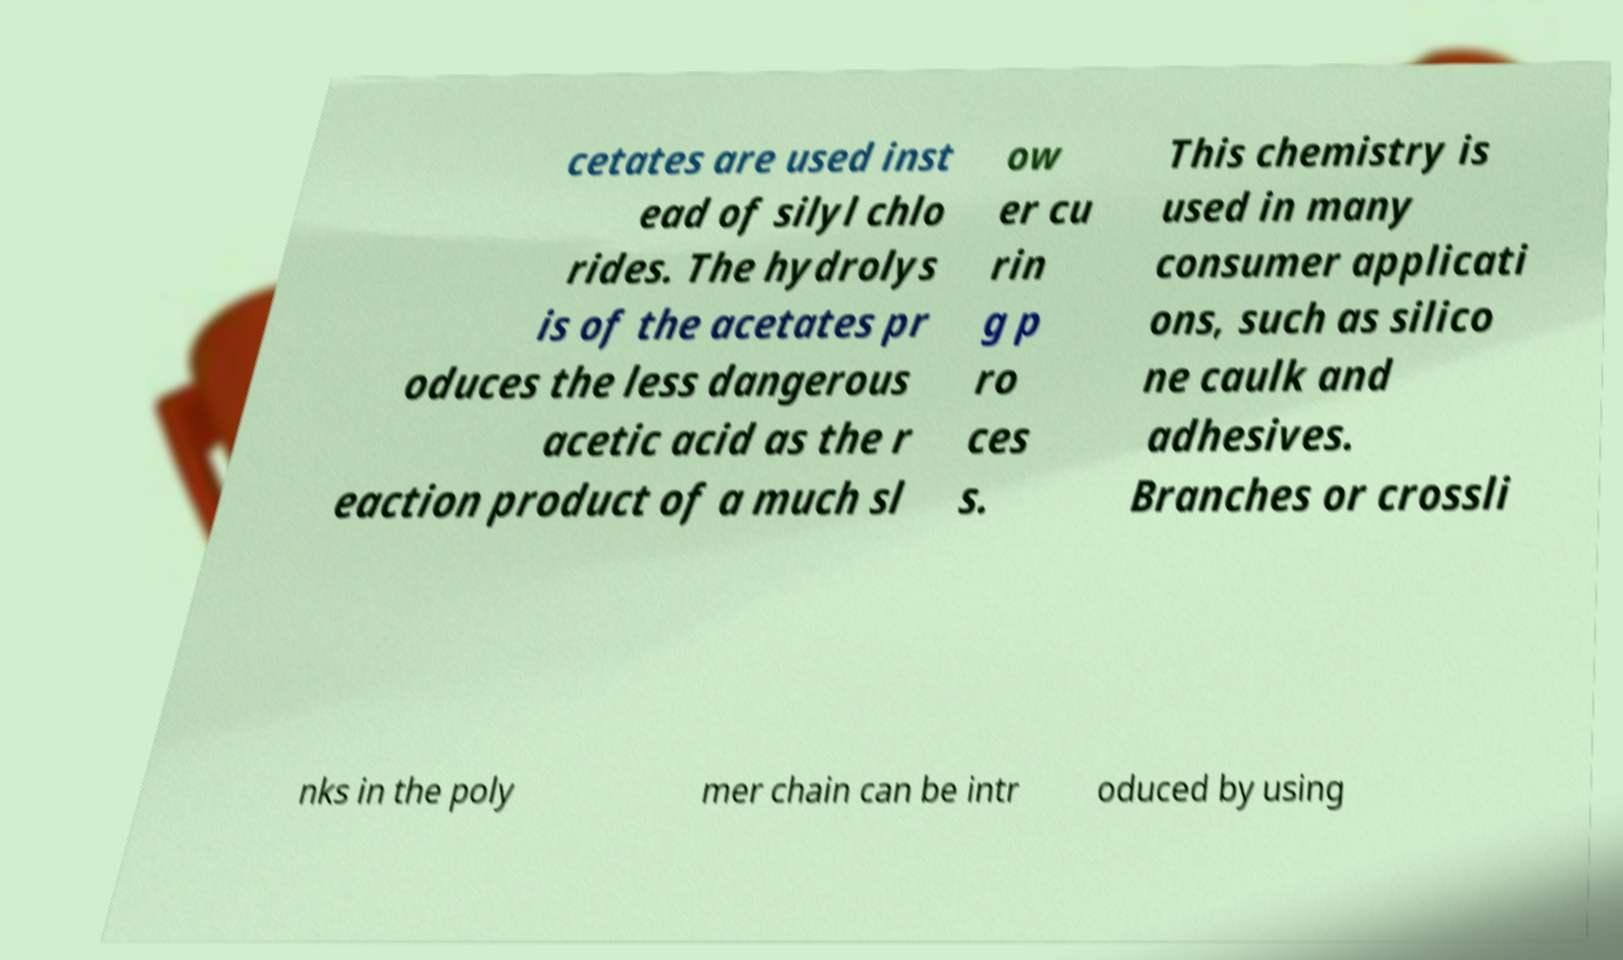For documentation purposes, I need the text within this image transcribed. Could you provide that? cetates are used inst ead of silyl chlo rides. The hydrolys is of the acetates pr oduces the less dangerous acetic acid as the r eaction product of a much sl ow er cu rin g p ro ces s. This chemistry is used in many consumer applicati ons, such as silico ne caulk and adhesives. Branches or crossli nks in the poly mer chain can be intr oduced by using 